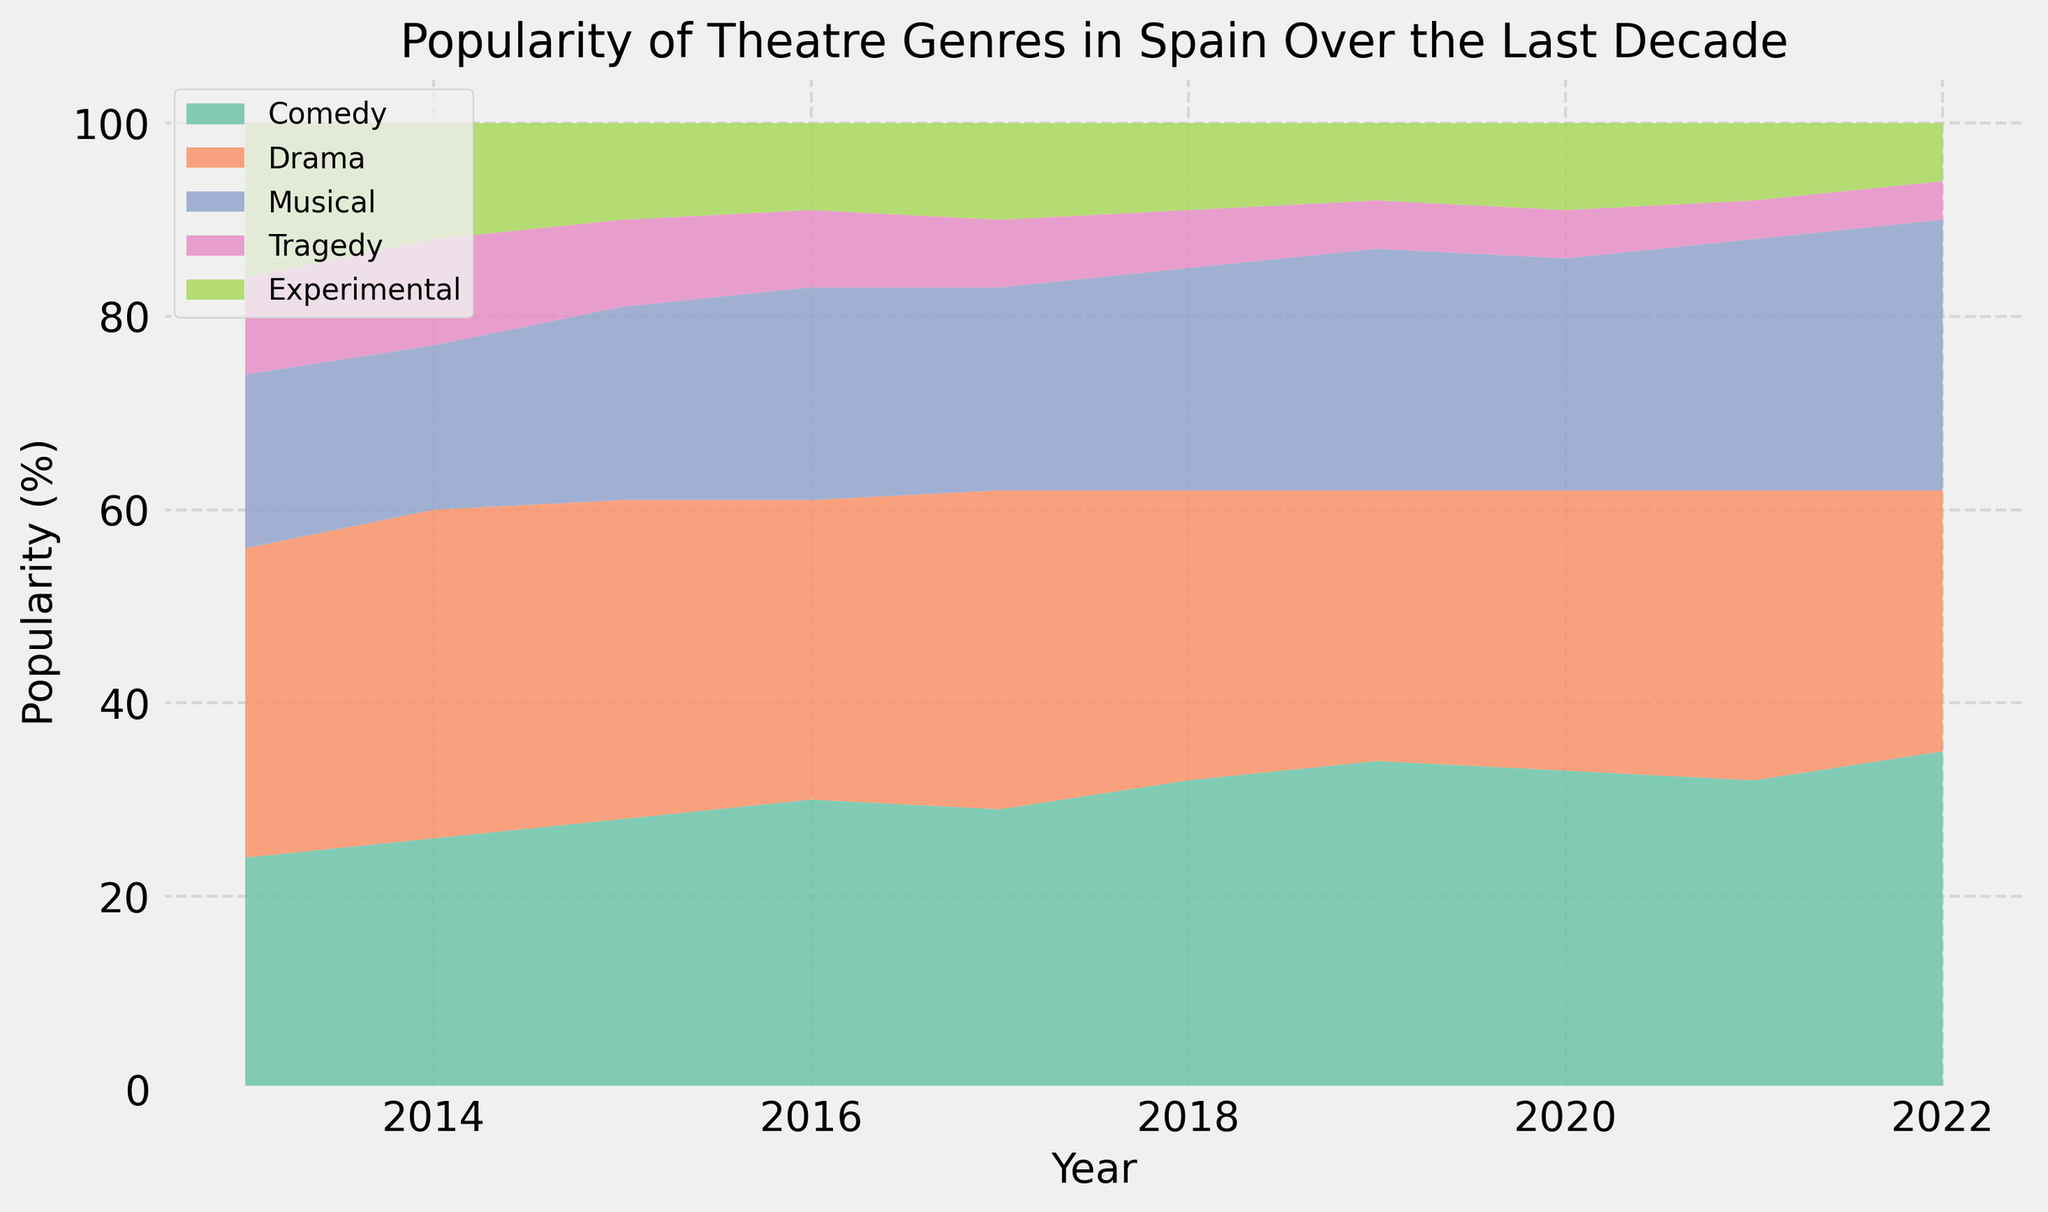What's the most popular genre in 2019? Look at the year 2019 and observe the segment heights in the area chart. The genre with the tallest segment is the most popular.
Answer: Comedy Which genre shows a consistent increase in popularity over the decade? Compare the heights of each genre's segment annually. Identify the genre whose segment height increases every year.
Answer: Comedy In which year did Experimental theatre see the biggest decrease in popularity compared to the previous year? Compare the height of Experimental theatre segments year by year and find the largest drop from one year to the next.
Answer: 2014 What is the sum of the percentages for Comedy and Musical genres in 2021? Look at the segment heights for Comedy and Musical in 2021, and add these values together. Comedy is 32% and Musical is 26%, so 32 + 26 = 58%.
Answer: 58% By how much did the popularity of Drama change from 2018 to 2019? Find the segment height for Drama in 2018 and 2019. Subtract the height in 2019 from the height in 2018. Drama in 2018 is 30%, and in 2019 it is 28%, so 30 - 28 = 2%.
Answer: 2% Which genre had the smallest range of popularity over the decade? Calculate the range (difference between the highest and lowest values) for each genre's segment heights from 2013 to 2022. The genre with the smallest range is the answer.
Answer: Experimental What is the average percentage of Tragedy theatre over the decade? Sum up the percentage values for Tragedy from 2013 to 2022 and then divide by the number of years (10). The values are 10, 11, 9, 8, 7, 6, 5, 5, 4, 4. The total sum is 69, and the average is 69/10 = 6.9%.
Answer: 6.9% Did any genre experience a sharp increase or decrease in one particular year? If yes, name the genre and the year. Look for noticeable jumps or drops in segment heights between consecutive years. Identify the year and genre with the most significant change. The Experimental genre decreased from 16% in 2013 to 12% in 2014.
Answer: Experimental, 2014 